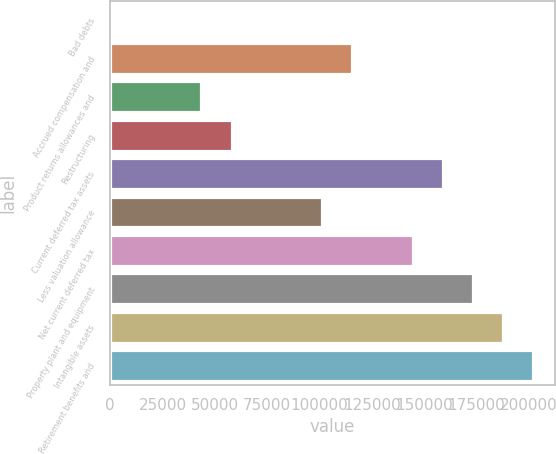Convert chart to OTSL. <chart><loc_0><loc_0><loc_500><loc_500><bar_chart><fcel>Bad debts<fcel>Accrued compensation and<fcel>Product returns allowances and<fcel>Restructuring<fcel>Current deferred tax assets<fcel>Less valuation allowance<fcel>Net current deferred tax<fcel>Property plant and equipment<fcel>Intangible assets<fcel>Retirement benefits and<nl><fcel>329<fcel>115755<fcel>43613.6<fcel>58041.8<fcel>159039<fcel>101326<fcel>144611<fcel>173467<fcel>187896<fcel>202324<nl></chart> 